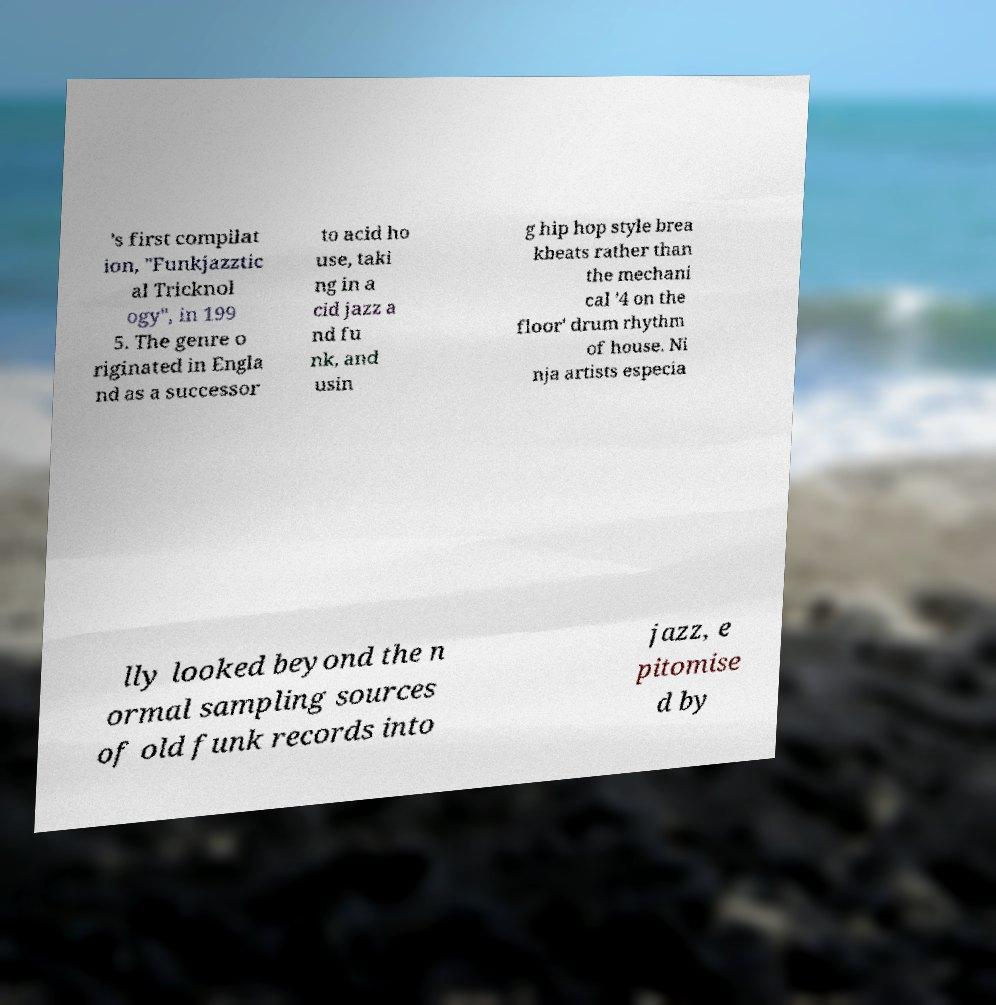Please read and relay the text visible in this image. What does it say? 's first compilat ion, "Funkjazztic al Tricknol ogy", in 199 5. The genre o riginated in Engla nd as a successor to acid ho use, taki ng in a cid jazz a nd fu nk, and usin g hip hop style brea kbeats rather than the mechani cal '4 on the floor' drum rhythm of house. Ni nja artists especia lly looked beyond the n ormal sampling sources of old funk records into jazz, e pitomise d by 